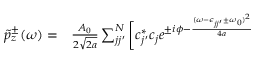<formula> <loc_0><loc_0><loc_500><loc_500>\begin{array} { r l } { \tilde { p } _ { z } ^ { \pm } ( \omega ) = } & \frac { A _ { 0 } } { 2 \sqrt { 2 a } } \sum _ { j j ^ { \prime } } ^ { N } \Big [ c _ { j ^ { \prime } } ^ { * } c _ { j } e ^ { \pm i \phi - \frac { ( \omega - \epsilon _ { j j ^ { \prime } } \pm \omega _ { 0 } ) ^ { 2 } } { 4 a } } } \end{array}</formula> 